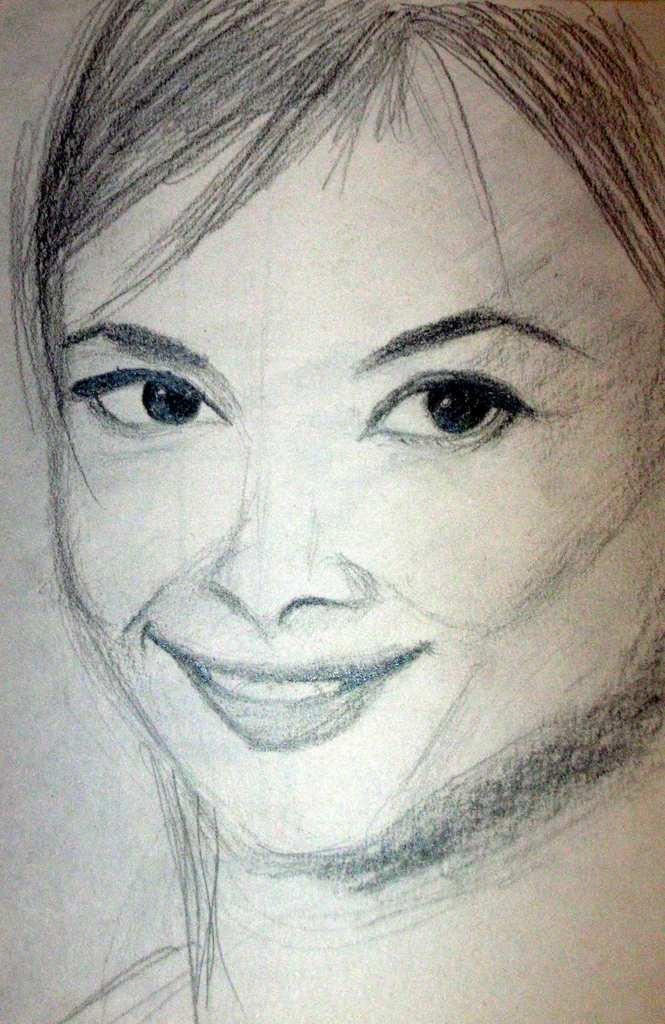What type of drawing is depicted in the image? The image contains a pencil sketch of a woman. What medium was used to create the drawing? The medium used to create the drawing is pencil. Can you describe the subject of the sketch? The subject of the sketch is a woman. What type of polish is being applied to the woman's nails in the image? There is no polish or nail application visible in the image, as it is a pencil sketch of a woman. 